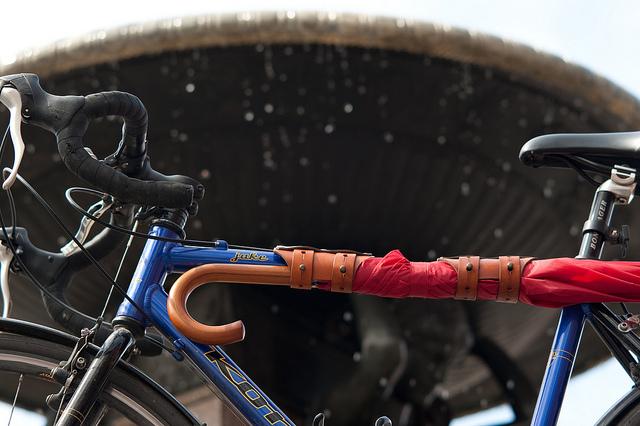How many people can ride this bike?
Give a very brief answer. 1. What color is this bicycle?
Keep it brief. Blue. What is strapped to the bicycle?
Keep it brief. Umbrella. 